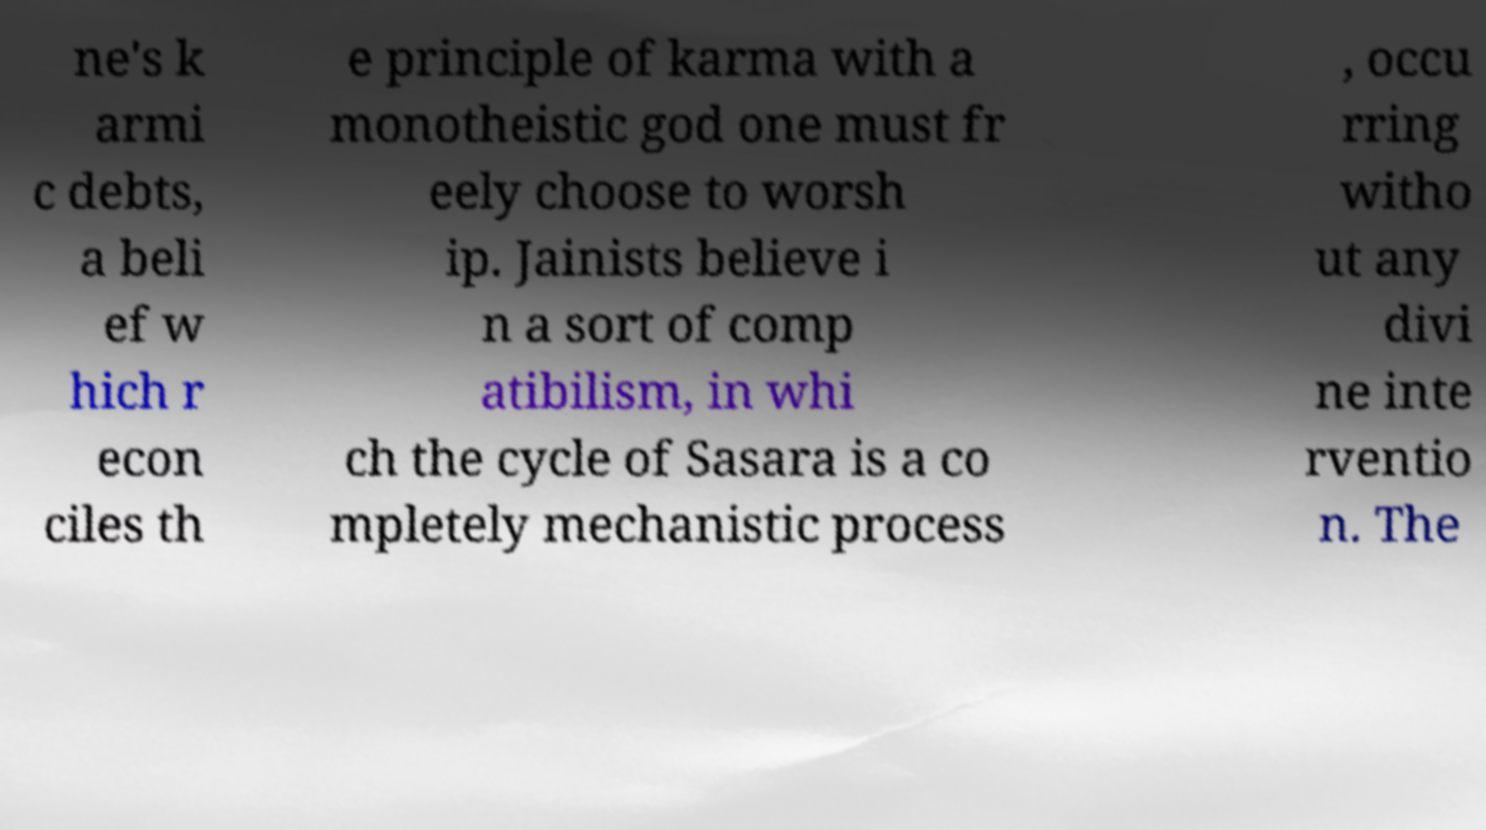Could you assist in decoding the text presented in this image and type it out clearly? ne's k armi c debts, a beli ef w hich r econ ciles th e principle of karma with a monotheistic god one must fr eely choose to worsh ip. Jainists believe i n a sort of comp atibilism, in whi ch the cycle of Sasara is a co mpletely mechanistic process , occu rring witho ut any divi ne inte rventio n. The 